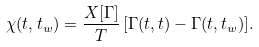<formula> <loc_0><loc_0><loc_500><loc_500>\chi ( t , t _ { w } ) = \frac { X [ \Gamma ] } { T } \, [ \Gamma ( t , t ) - \Gamma ( t , t _ { w } ) ] .</formula> 